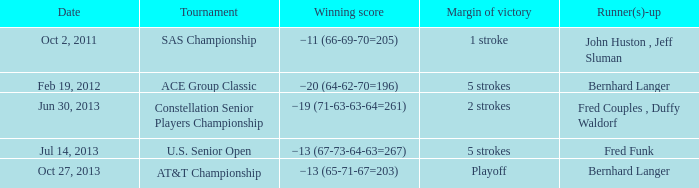Which event was scheduled for july 14, 2013? U.S. Senior Open. Would you be able to parse every entry in this table? {'header': ['Date', 'Tournament', 'Winning score', 'Margin of victory', 'Runner(s)-up'], 'rows': [['Oct 2, 2011', 'SAS Championship', '−11 (66-69-70=205)', '1 stroke', 'John Huston , Jeff Sluman'], ['Feb 19, 2012', 'ACE Group Classic', '−20 (64-62-70=196)', '5 strokes', 'Bernhard Langer'], ['Jun 30, 2013', 'Constellation Senior Players Championship', '−19 (71-63-63-64=261)', '2 strokes', 'Fred Couples , Duffy Waldorf'], ['Jul 14, 2013', 'U.S. Senior Open', '−13 (67-73-64-63=267)', '5 strokes', 'Fred Funk'], ['Oct 27, 2013', 'AT&T Championship', '−13 (65-71-67=203)', 'Playoff', 'Bernhard Langer']]} 